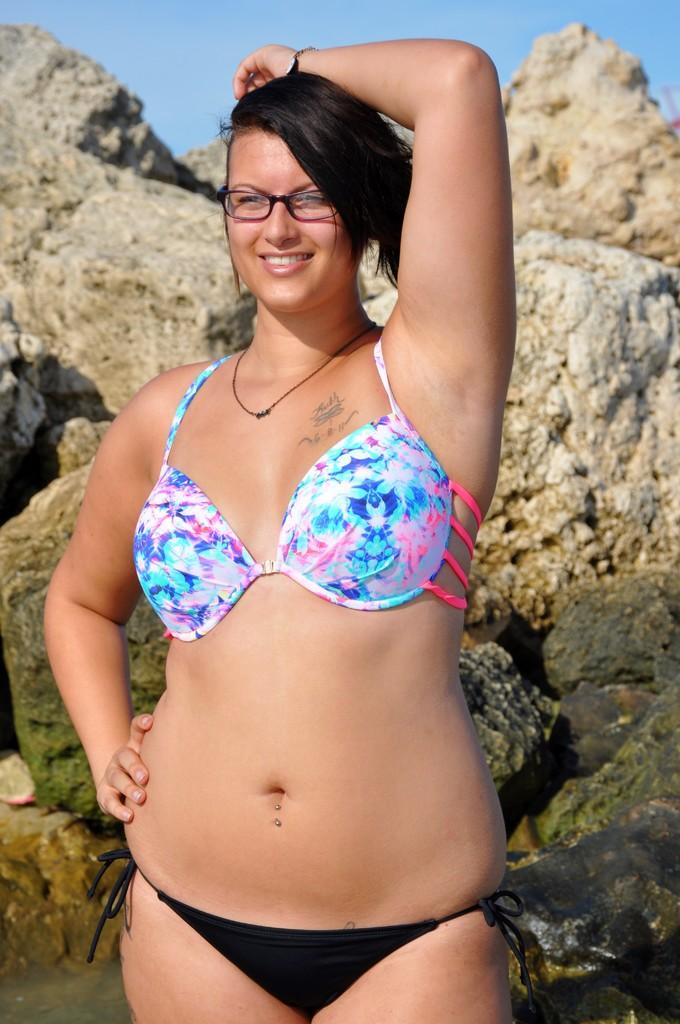What is the main subject of the image? There is a woman standing in the center of the image. What can be seen in the background of the image? There are rocks and the sky visible in the background of the image. What type of butter is being used by the woman in the image? There is no butter present in the image; it features a woman standing in the center and rocks and the sky in the background. 